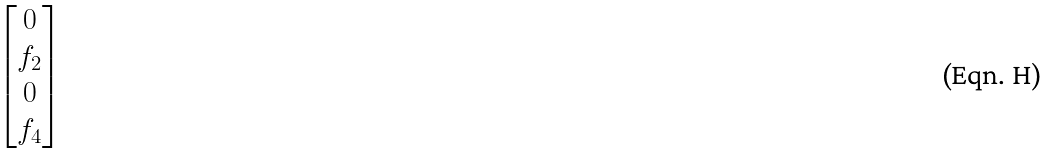Convert formula to latex. <formula><loc_0><loc_0><loc_500><loc_500>\begin{bmatrix} 0 \\ f _ { 2 } \\ 0 \\ f _ { 4 } \end{bmatrix}</formula> 